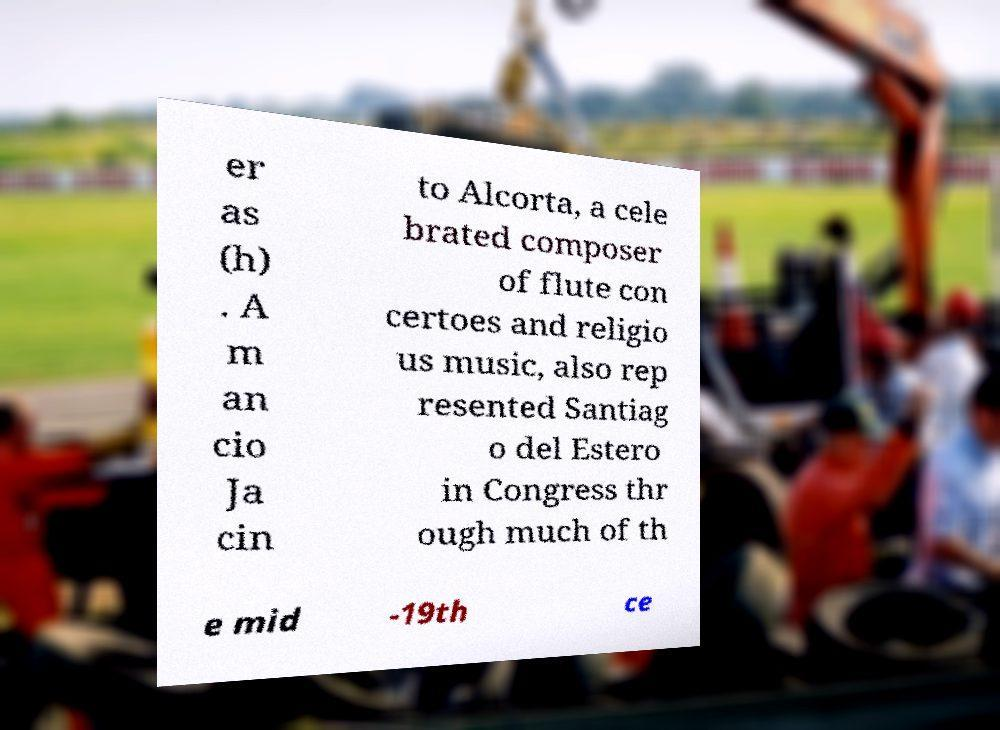Please read and relay the text visible in this image. What does it say? er as (h) . A m an cio Ja cin to Alcorta, a cele brated composer of flute con certoes and religio us music, also rep resented Santiag o del Estero in Congress thr ough much of th e mid -19th ce 